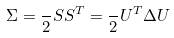Convert formula to latex. <formula><loc_0><loc_0><loc_500><loc_500>\Sigma = \frac { } { 2 } S S ^ { T } = \frac { } { 2 } U ^ { T } \Delta U \</formula> 